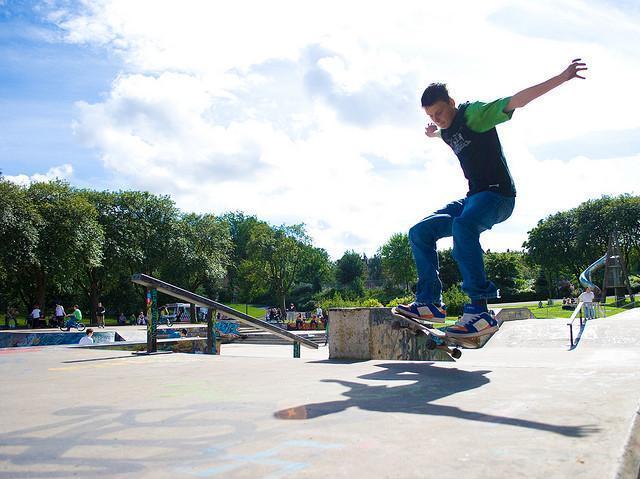How many people are in the picture?
Give a very brief answer. 2. 